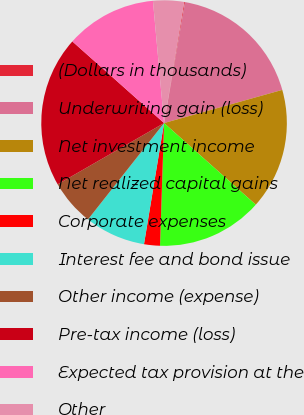Convert chart. <chart><loc_0><loc_0><loc_500><loc_500><pie_chart><fcel>(Dollars in thousands)<fcel>Underwriting gain (loss)<fcel>Net investment income<fcel>Net realized capital gains<fcel>Corporate expenses<fcel>Interest fee and bond issue<fcel>Other income (expense)<fcel>Pre-tax income (loss)<fcel>Expected tax provision at the<fcel>Other<nl><fcel>0.11%<fcel>17.91%<fcel>15.93%<fcel>13.95%<fcel>2.09%<fcel>8.02%<fcel>6.05%<fcel>19.89%<fcel>11.98%<fcel>4.07%<nl></chart> 